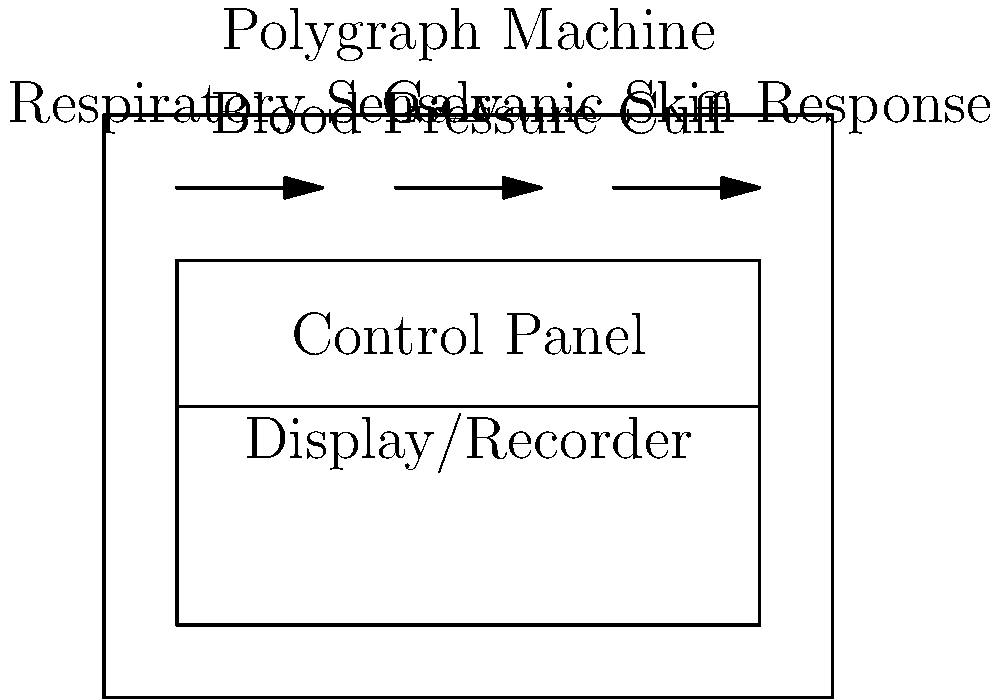As a librarian maintaining a comprehensive law and crime section, you encounter a book discussing polygraph machines. The book includes a schematic diagram of a polygraph. Which component of the polygraph machine is responsible for detecting changes in skin conductivity, often associated with stress or anxiety during lie detection? To answer this question, let's break down the components of a polygraph machine as shown in the schematic:

1. The diagram shows three main sensors:
   a) Respiratory Sensor
   b) Blood Pressure Cuff
   c) Galvanic Skin Response

2. Each of these sensors measures a different physiological response:
   a) Respiratory Sensor: Measures breathing rate and depth
   b) Blood Pressure Cuff: Measures blood pressure and heart rate
   c) Galvanic Skin Response: Measures skin conductivity

3. Changes in skin conductivity are often associated with stress or anxiety, which may occur when a person is lying.

4. The component that specifically measures skin conductivity is the Galvanic Skin Response sensor.

5. In lie detection, increased skin conductivity (due to increased sweat gland activity) may indicate heightened stress levels, potentially suggesting deception.

Therefore, the component responsible for detecting changes in skin conductivity during lie detection is the Galvanic Skin Response sensor.
Answer: Galvanic Skin Response sensor 